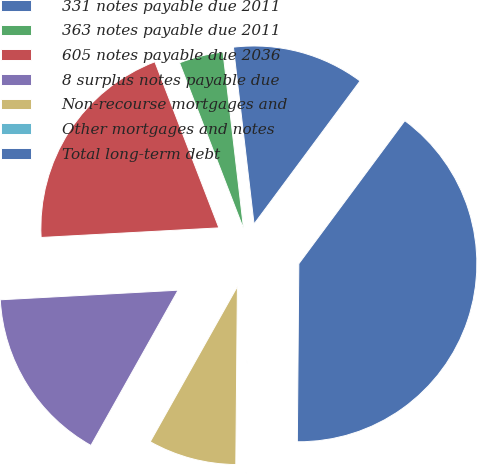Convert chart. <chart><loc_0><loc_0><loc_500><loc_500><pie_chart><fcel>331 notes payable due 2011<fcel>363 notes payable due 2011<fcel>605 notes payable due 2036<fcel>8 surplus notes payable due<fcel>Non-recourse mortgages and<fcel>Other mortgages and notes<fcel>Total long-term debt<nl><fcel>12.0%<fcel>4.01%<fcel>20.0%<fcel>16.0%<fcel>8.0%<fcel>0.01%<fcel>39.98%<nl></chart> 